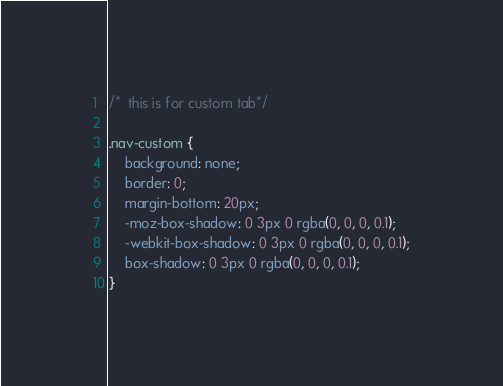Convert code to text. <code><loc_0><loc_0><loc_500><loc_500><_CSS_>/*  this is for custom tab*/

.nav-custom {
    background: none;
    border: 0;
    margin-bottom: 20px;
    -moz-box-shadow: 0 3px 0 rgba(0, 0, 0, 0.1);
    -webkit-box-shadow: 0 3px 0 rgba(0, 0, 0, 0.1);
    box-shadow: 0 3px 0 rgba(0, 0, 0, 0.1);
}
</code> 